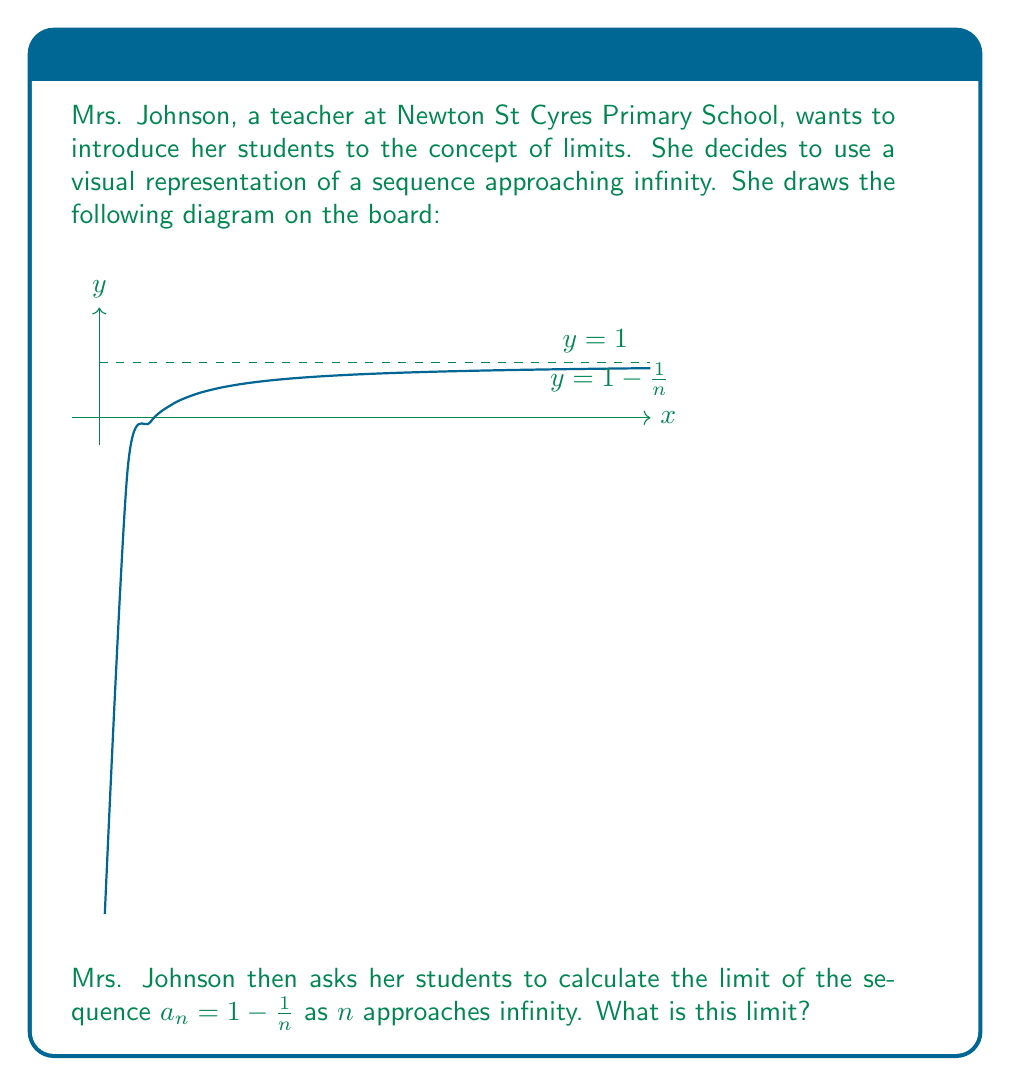Can you solve this math problem? Let's approach this step-by-step:

1) First, we need to understand what happens to $\frac{1}{n}$ as $n$ gets very large (approaches infinity):
   
   As $n \to \infty$, $\frac{1}{n} \to 0$

2) Now, let's look at our sequence: $a_n = 1 - \frac{1}{n}$

3) As $n$ approaches infinity, we can substitute what we know about $\frac{1}{n}$:

   $\lim_{n \to \infty} a_n = \lim_{n \to \infty} (1 - \frac{1}{n}) = 1 - \lim_{n \to \infty} \frac{1}{n} = 1 - 0 = 1$

4) We can also see this visually from the graph. As $n$ gets larger (moving right on the x-axis), the curve gets closer and closer to the dashed line at $y = 1$.

Therefore, the limit of the sequence as $n$ approaches infinity is 1.
Answer: $\lim_{n \to \infty} (1 - \frac{1}{n}) = 1$ 